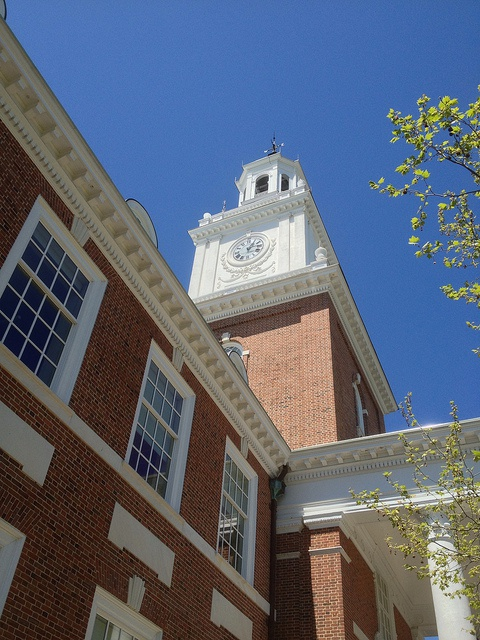Describe the objects in this image and their specific colors. I can see a clock in gray, lightgray, and darkgray tones in this image. 